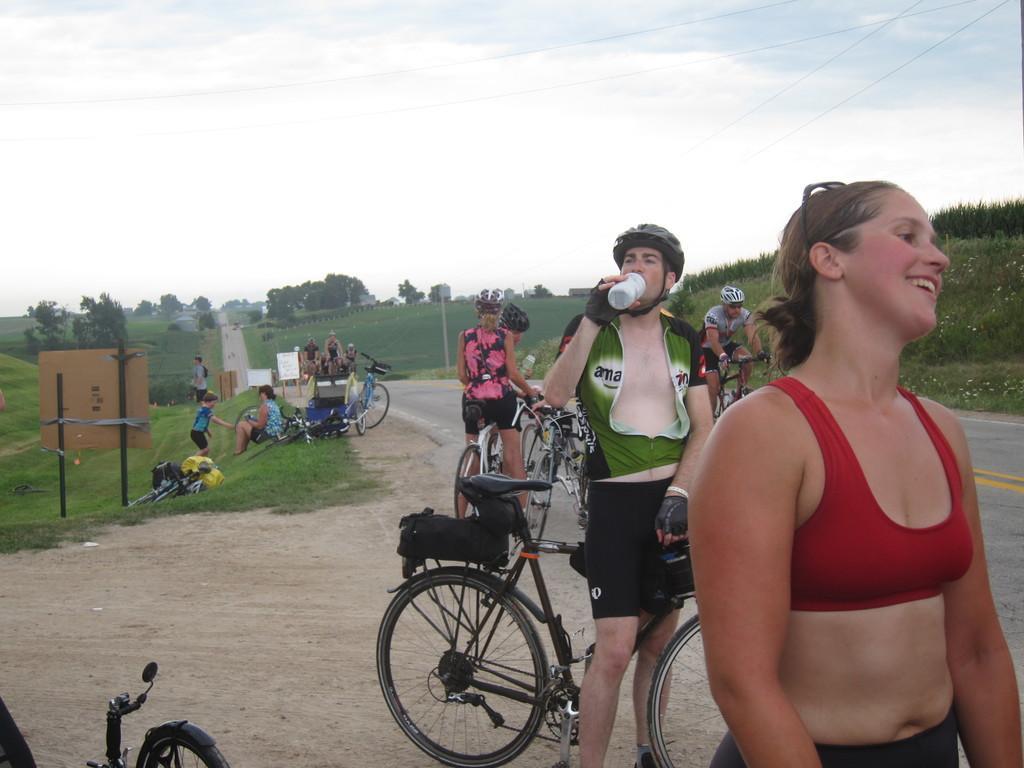How would you summarize this image in a sentence or two? The person wearing green jacket is drinking water and there is a cycle in between him and the lady wearing red jacket is standing at the right corner and there are group of riders in the background and the background is greenery. 